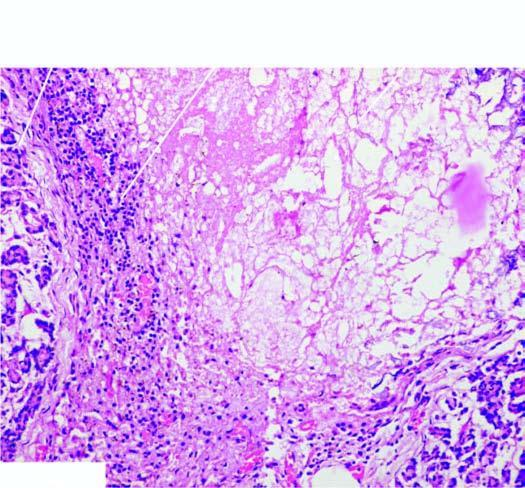s inbox destruction of acinar tissue and presence of dystrophic calcification?
Answer the question using a single word or phrase. No 